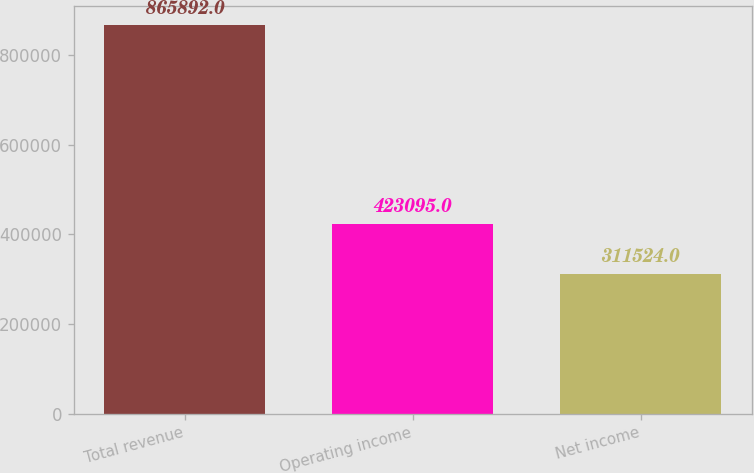<chart> <loc_0><loc_0><loc_500><loc_500><bar_chart><fcel>Total revenue<fcel>Operating income<fcel>Net income<nl><fcel>865892<fcel>423095<fcel>311524<nl></chart> 